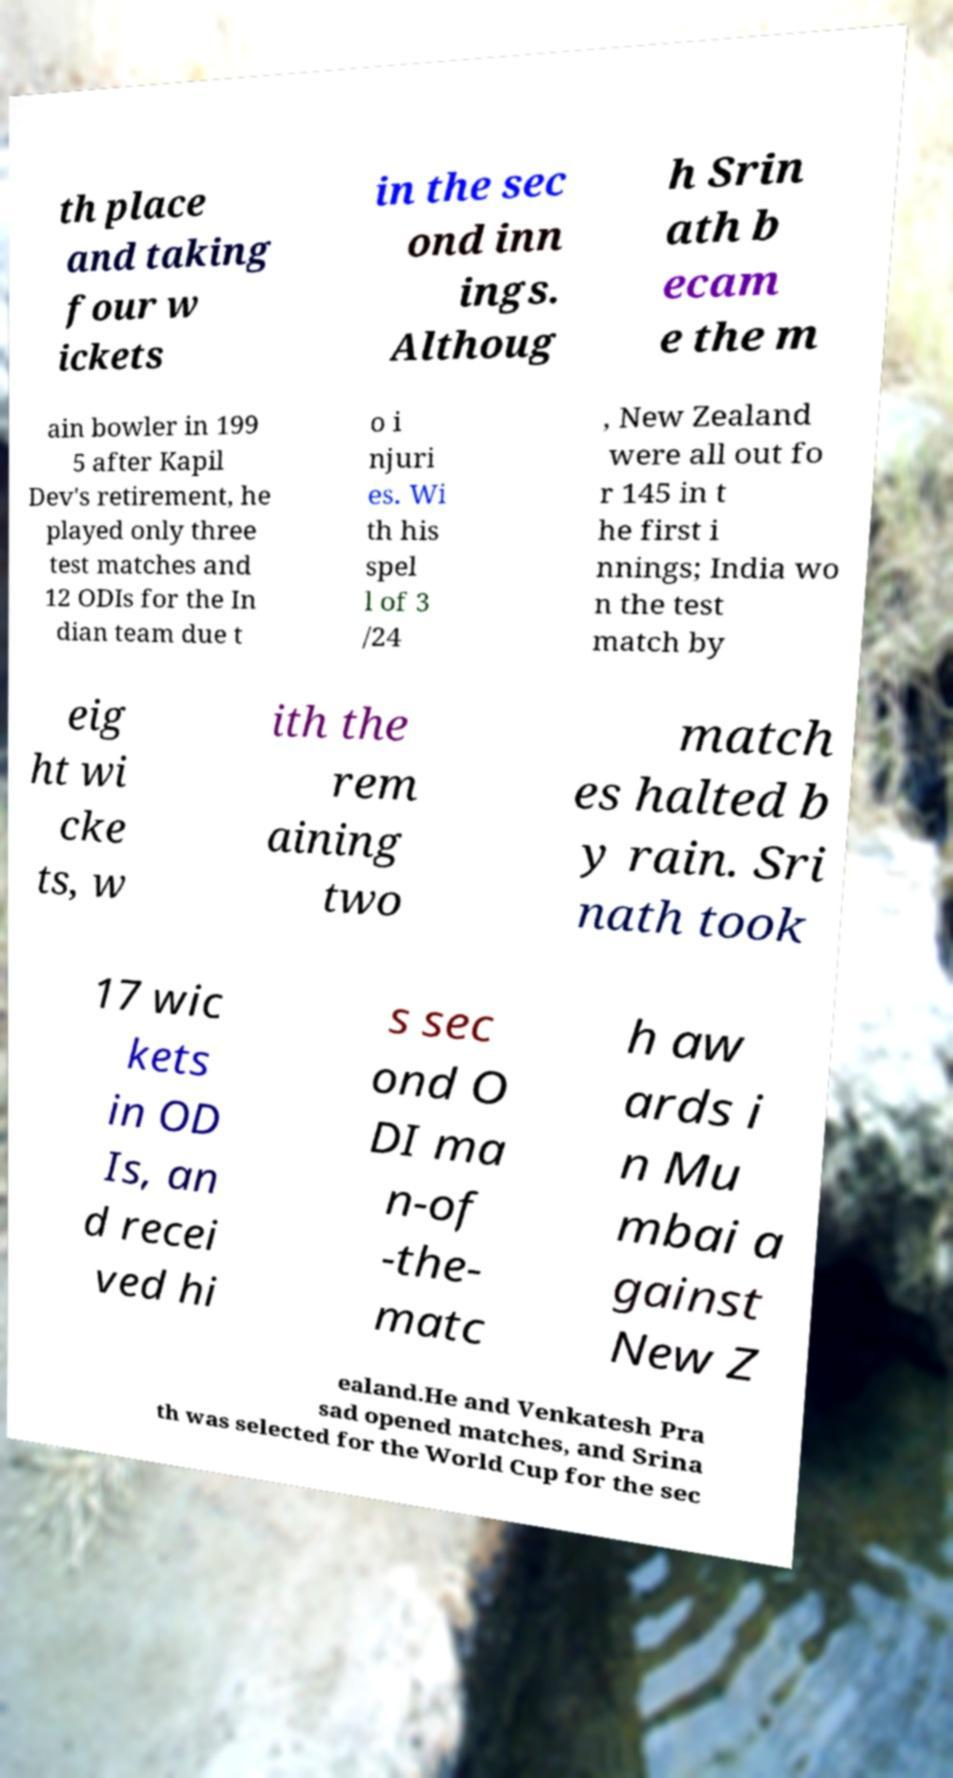Please identify and transcribe the text found in this image. th place and taking four w ickets in the sec ond inn ings. Althoug h Srin ath b ecam e the m ain bowler in 199 5 after Kapil Dev's retirement, he played only three test matches and 12 ODIs for the In dian team due t o i njuri es. Wi th his spel l of 3 /24 , New Zealand were all out fo r 145 in t he first i nnings; India wo n the test match by eig ht wi cke ts, w ith the rem aining two match es halted b y rain. Sri nath took 17 wic kets in OD Is, an d recei ved hi s sec ond O DI ma n-of -the- matc h aw ards i n Mu mbai a gainst New Z ealand.He and Venkatesh Pra sad opened matches, and Srina th was selected for the World Cup for the sec 